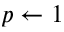<formula> <loc_0><loc_0><loc_500><loc_500>p \leftarrow 1</formula> 